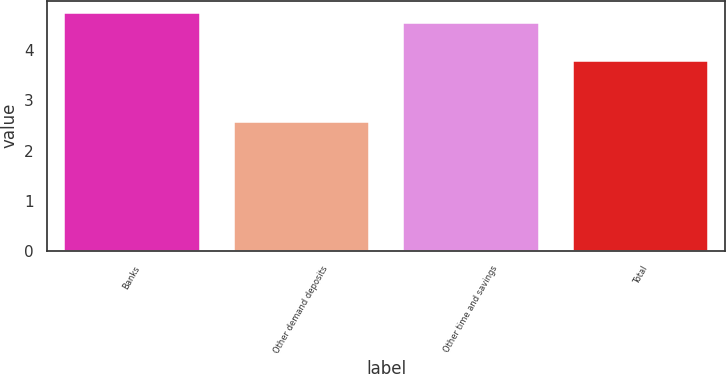<chart> <loc_0><loc_0><loc_500><loc_500><bar_chart><fcel>Banks<fcel>Other demand deposits<fcel>Other time and savings<fcel>Total<nl><fcel>4.75<fcel>2.57<fcel>4.54<fcel>3.79<nl></chart> 